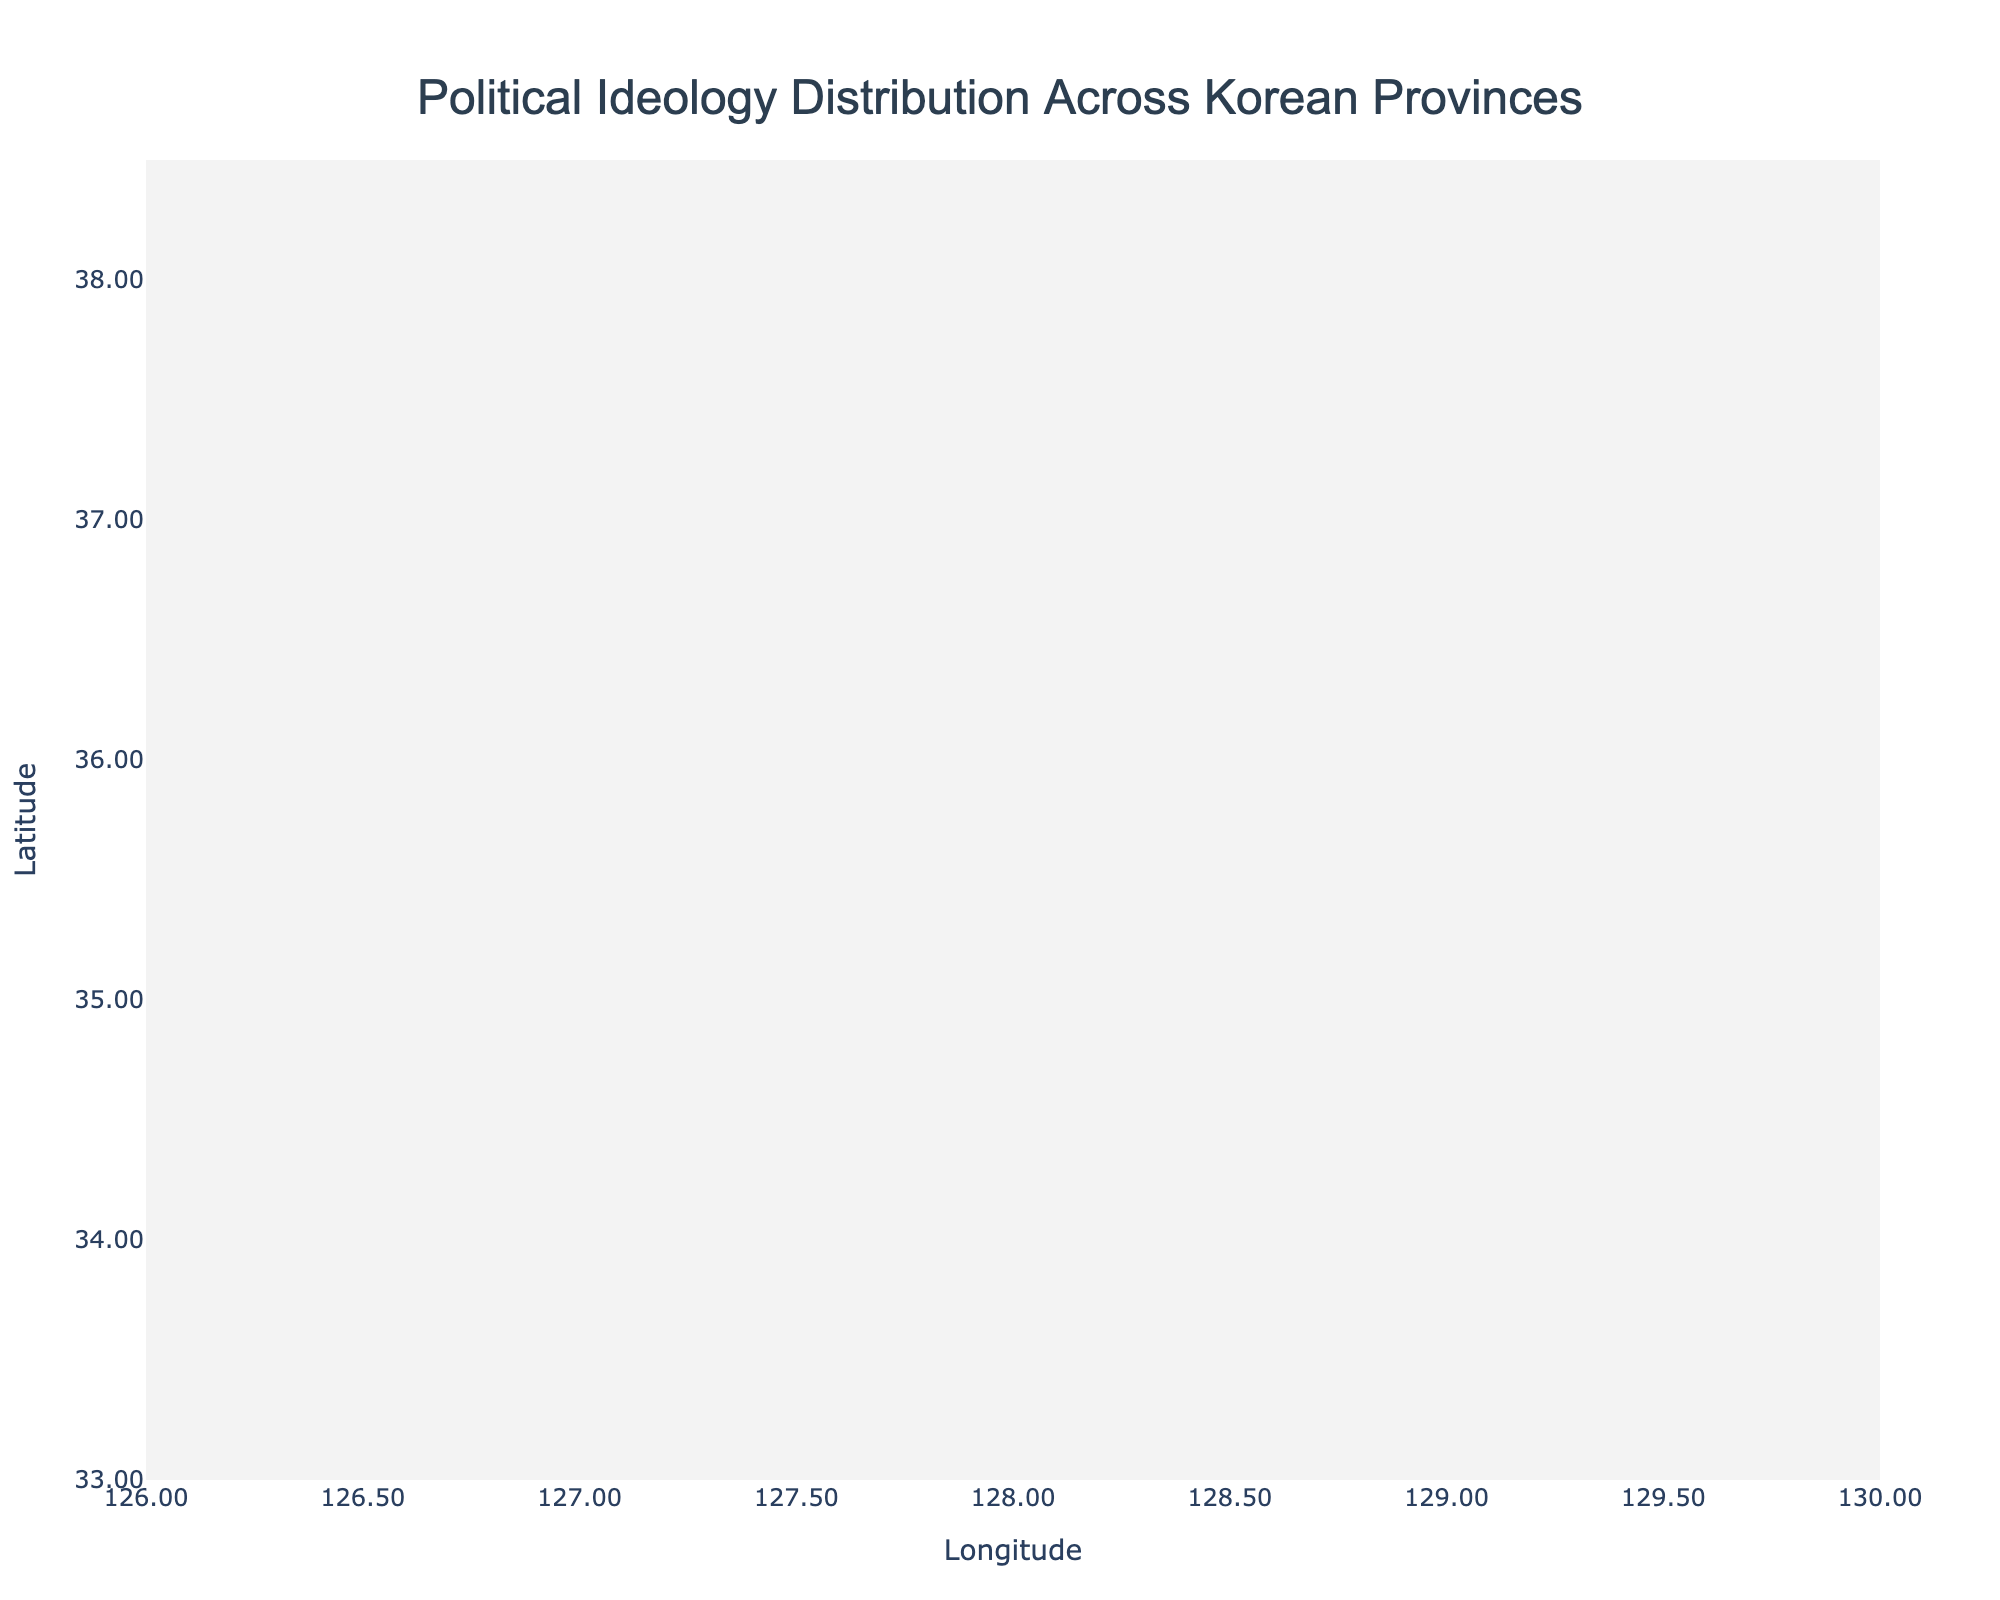Which province has the most conservative ideology and shows the highest directional influence? By examining the figure, we can identify that Daegu has a conservative ideology indicated by the red color and the longest arrow among conservative provinces, suggesting the highest directional influence.
Answer: Daegu What direction does the political influence in Gwangju move toward? Gwangju is indicated as a progressive province in green, and by looking at the arrow direction in Gwangju, it points slightly upwards and mostly to the right, indicating a northeast directional influence.
Answer: Northeast Which provinces exhibit a liberal ideology, and what are their directional influences? The liberal provinces are shown in blue. By looking at the figure, Seoul and Gyeonggi are marked with a liberal ideology. Their directional influences are slightly southwest for Seoul and southwest for Gyeonggi as indicated by their respective arrows.
Answer: Seoul: Southwest, Gyeonggi: Southwest How does the directional influence in Busan compare to those in other conservative provinces? Busan has a red arrow showing conservative ideology and a slight northeast directional influence. By comparing with other conservative arrows (Daegu, Ulsan, Gangwon, Gyeongbuk, and Gyeongnam), Busan’s influence appears moderate, neither the longest nor shortest among them.
Answer: Moderate compared to other conservative provinces What overall trend is observed regarding the locations and directional influences of progressive provinces? Progressive provinces are represented in green and include Gwangju, Jeonbuk, and Jeonnam. By observing their arrows, we see Gwangju with a slight northeast, Jeonbuk with a mildly south-eastward, and Jeonnam with a southwest influence, suggesting progressive provinces have diverse directional influences.
Answer: Diverse directional influences How many provinces exhibit a moderate ideology, and what are the directions of their political influences? Moderate ideology provinces are shown in orange. Observing the figure, Incheon, Daejeon, Sejong, Chungbuk, and Chungnam are moderate. Their directional influences are southwest, southeast, northeast, southeast, and northeast respectively as indicated by their arrows.
Answer: Five provinces; Incheon: Southwest, Daejeon: Southeast, Sejong: Northeast, Chungbuk: Southeast, Chungnam: Northeast In which quadrant of the map are most conservative provinces located? By looking at the figure and noting the positions of red-labeled conservative points (mostly Busan, Daegu, Ulsan, Gangwon, Gyeongbuk, Gyeongnam), we can determine that the majority are located in the southeast quadrant of the map.
Answer: Southeast quadrant Are there any provinces with identical political ideologies but opposite directional influences? By carefully examining the arrows for same-colored points, Incheon and Chungnam both have moderate ideologies in orange. However, Incheon has a southwest influence while Chungnam has a northeast influence, which are opposite directions.
Answer: Incheon and Chungnam 